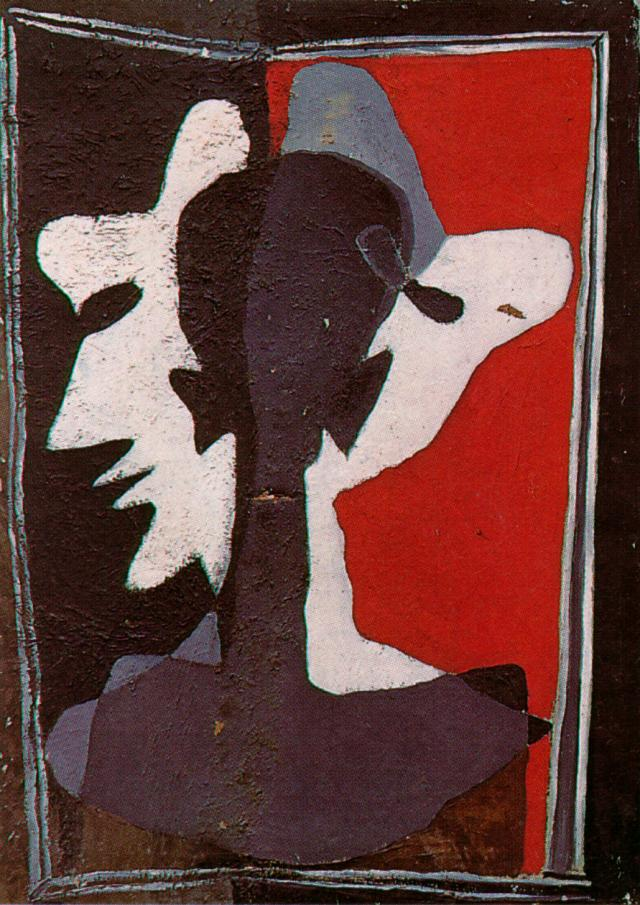If you could step into this artwork, what environment or world would you find yourself in? Stepping into this artwork, you would find yourself in a surreal, moody environment where the laws of physics and reality seem fluid and ever-changing. The stark red sky looms overhead, casting a potent sense of urgency and passion. The rough, textured ground beneath your feet is uneven and reflective of the abstract terrain. Faces, silhouettes, and fragments of people emerge and recede in the shadows, symbolizing the constant flux of identity and emotion. It's a world where space is not bound by physical constraints but is instead an expansive canvas for creativity and introspection. The tension in this realm is palpable, yet it draws you in with a magnetic allure, inviting endless exploration and existential reflection. 